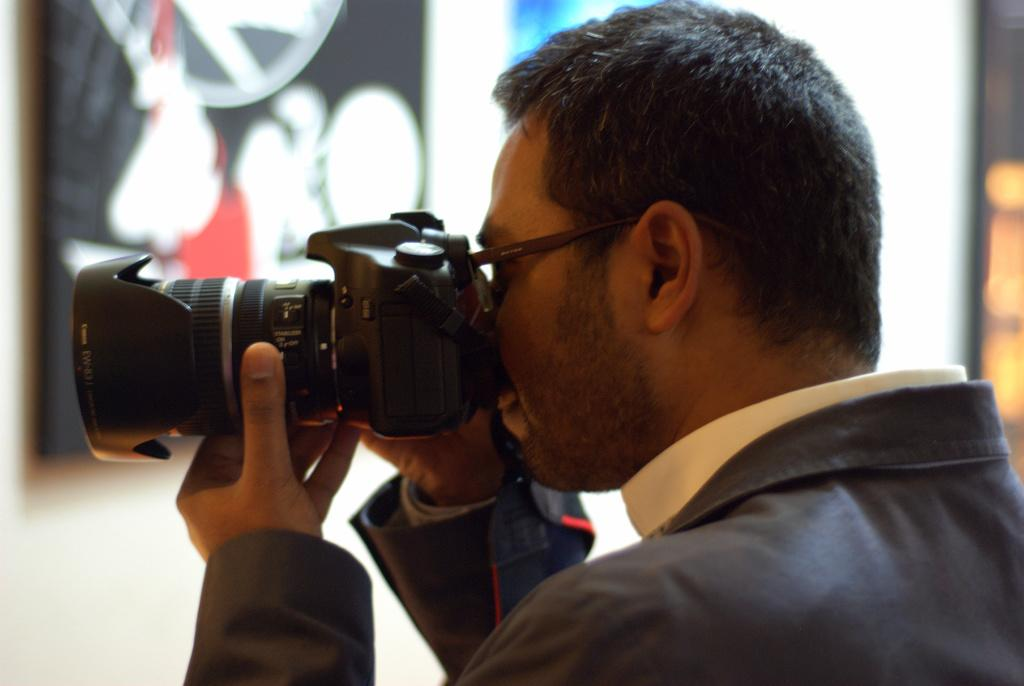Who is present in the image? There is a person in the image. Where is the person located in the image? The person is on the right side of the image. What is the person holding in the image? The person is holding a camera. What is the person doing with the camera? The person is clicking an image with the camera. Reasoning: Let' Let's think step by step in order to produce the conversation. We start by identifying the main subject in the image, which is the person. Then, we describe the person's location, the object they are holding, and their action. Each question is designed to elicit a specific detail about the image that is known from the provided facts. Absurd Question/Answer: What type of flesh can be seen on the person's hand in the image? There is no flesh visible on the person's hand in the image, as the person is holding a camera and the focus is on the camera rather than the person's hand. 